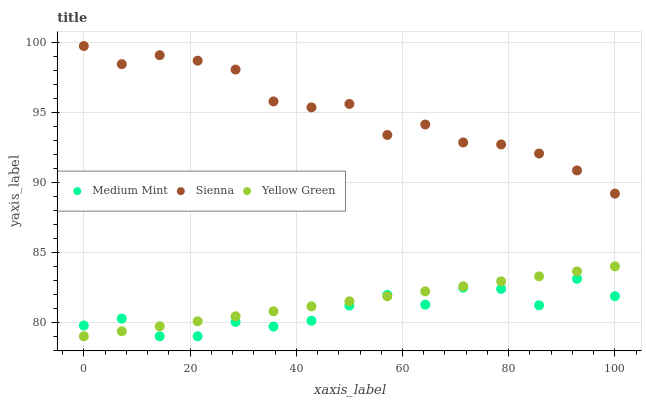Does Medium Mint have the minimum area under the curve?
Answer yes or no. Yes. Does Sienna have the maximum area under the curve?
Answer yes or no. Yes. Does Yellow Green have the minimum area under the curve?
Answer yes or no. No. Does Yellow Green have the maximum area under the curve?
Answer yes or no. No. Is Yellow Green the smoothest?
Answer yes or no. Yes. Is Medium Mint the roughest?
Answer yes or no. Yes. Is Sienna the smoothest?
Answer yes or no. No. Is Sienna the roughest?
Answer yes or no. No. Does Medium Mint have the lowest value?
Answer yes or no. Yes. Does Sienna have the lowest value?
Answer yes or no. No. Does Sienna have the highest value?
Answer yes or no. Yes. Does Yellow Green have the highest value?
Answer yes or no. No. Is Medium Mint less than Sienna?
Answer yes or no. Yes. Is Sienna greater than Yellow Green?
Answer yes or no. Yes. Does Medium Mint intersect Yellow Green?
Answer yes or no. Yes. Is Medium Mint less than Yellow Green?
Answer yes or no. No. Is Medium Mint greater than Yellow Green?
Answer yes or no. No. Does Medium Mint intersect Sienna?
Answer yes or no. No. 